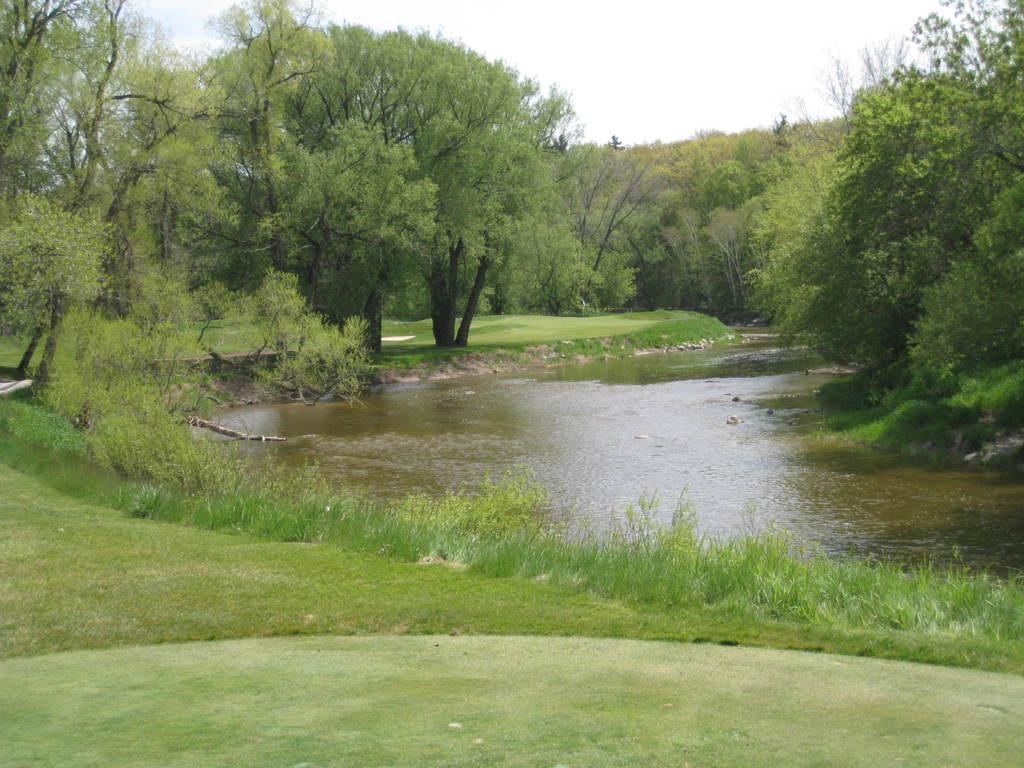How would you summarize this image in a sentence or two? In the picture I can see a greenery ground and there is water in front of it and there are trees on either sides of it. 